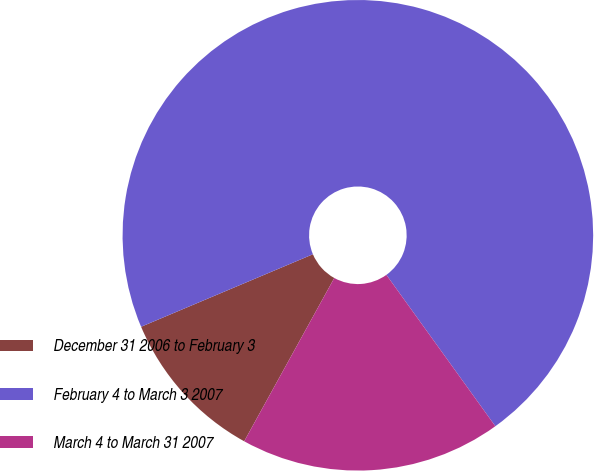<chart> <loc_0><loc_0><loc_500><loc_500><pie_chart><fcel>December 31 2006 to February 3<fcel>February 4 to March 3 2007<fcel>March 4 to March 31 2007<nl><fcel>10.62%<fcel>71.43%<fcel>17.96%<nl></chart> 